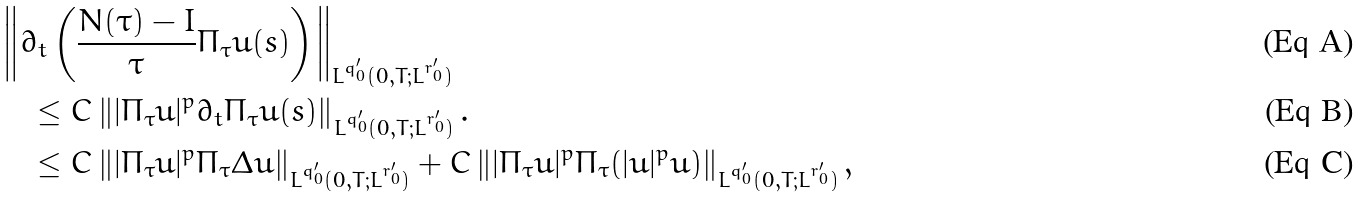Convert formula to latex. <formula><loc_0><loc_0><loc_500><loc_500>& \left \| \partial _ { t } \left ( \frac { N ( \tau ) - I } { \tau } \Pi _ { \tau } u ( s ) \right ) \right \| _ { L ^ { q _ { 0 } ^ { \prime } } ( 0 , T ; L ^ { r _ { 0 } ^ { \prime } } ) } \\ & \quad \leq C \left \| | \Pi _ { \tau } u | ^ { p } \partial _ { t } \Pi _ { \tau } u ( s ) \right \| _ { L ^ { q _ { 0 } ^ { \prime } } ( 0 , T ; L ^ { r _ { 0 } ^ { \prime } } ) } . \\ & \quad \leq C \left \| | \Pi _ { \tau } u | ^ { p } \Pi _ { \tau } \Delta u \right \| _ { L ^ { q _ { 0 } ^ { \prime } } ( 0 , T ; L ^ { r _ { 0 } ^ { \prime } } ) } + C \left \| | \Pi _ { \tau } u | ^ { p } \Pi _ { \tau } ( | u | ^ { p } u ) \right \| _ { L ^ { q _ { 0 } ^ { \prime } } ( 0 , T ; L ^ { r _ { 0 } ^ { \prime } } ) } ,</formula> 